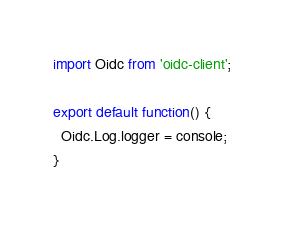<code> <loc_0><loc_0><loc_500><loc_500><_TypeScript_>import Oidc from 'oidc-client';

export default function() {
  Oidc.Log.logger = console;
}
</code> 